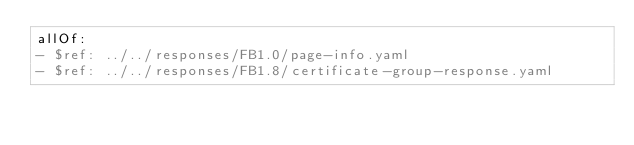<code> <loc_0><loc_0><loc_500><loc_500><_YAML_>allOf:
- $ref: ../../responses/FB1.0/page-info.yaml
- $ref: ../../responses/FB1.8/certificate-group-response.yaml
</code> 